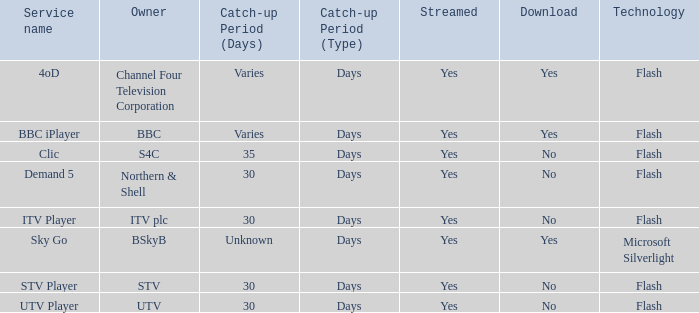What is the Catch-up period for UTV? 30 days. 